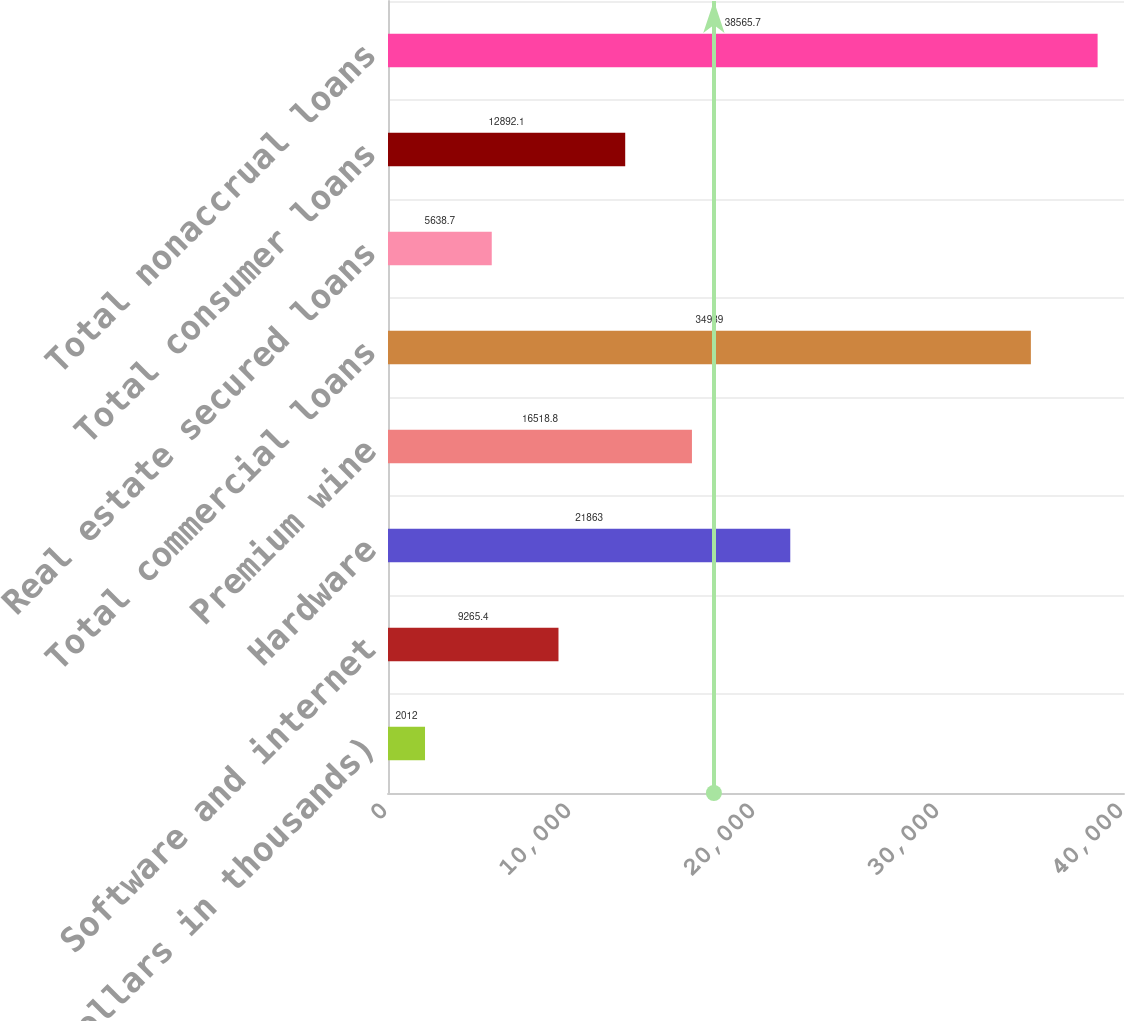Convert chart to OTSL. <chart><loc_0><loc_0><loc_500><loc_500><bar_chart><fcel>(Dollars in thousands)<fcel>Software and internet<fcel>Hardware<fcel>Premium wine<fcel>Total commercial loans<fcel>Real estate secured loans<fcel>Total consumer loans<fcel>Total nonaccrual loans<nl><fcel>2012<fcel>9265.4<fcel>21863<fcel>16518.8<fcel>34939<fcel>5638.7<fcel>12892.1<fcel>38565.7<nl></chart> 